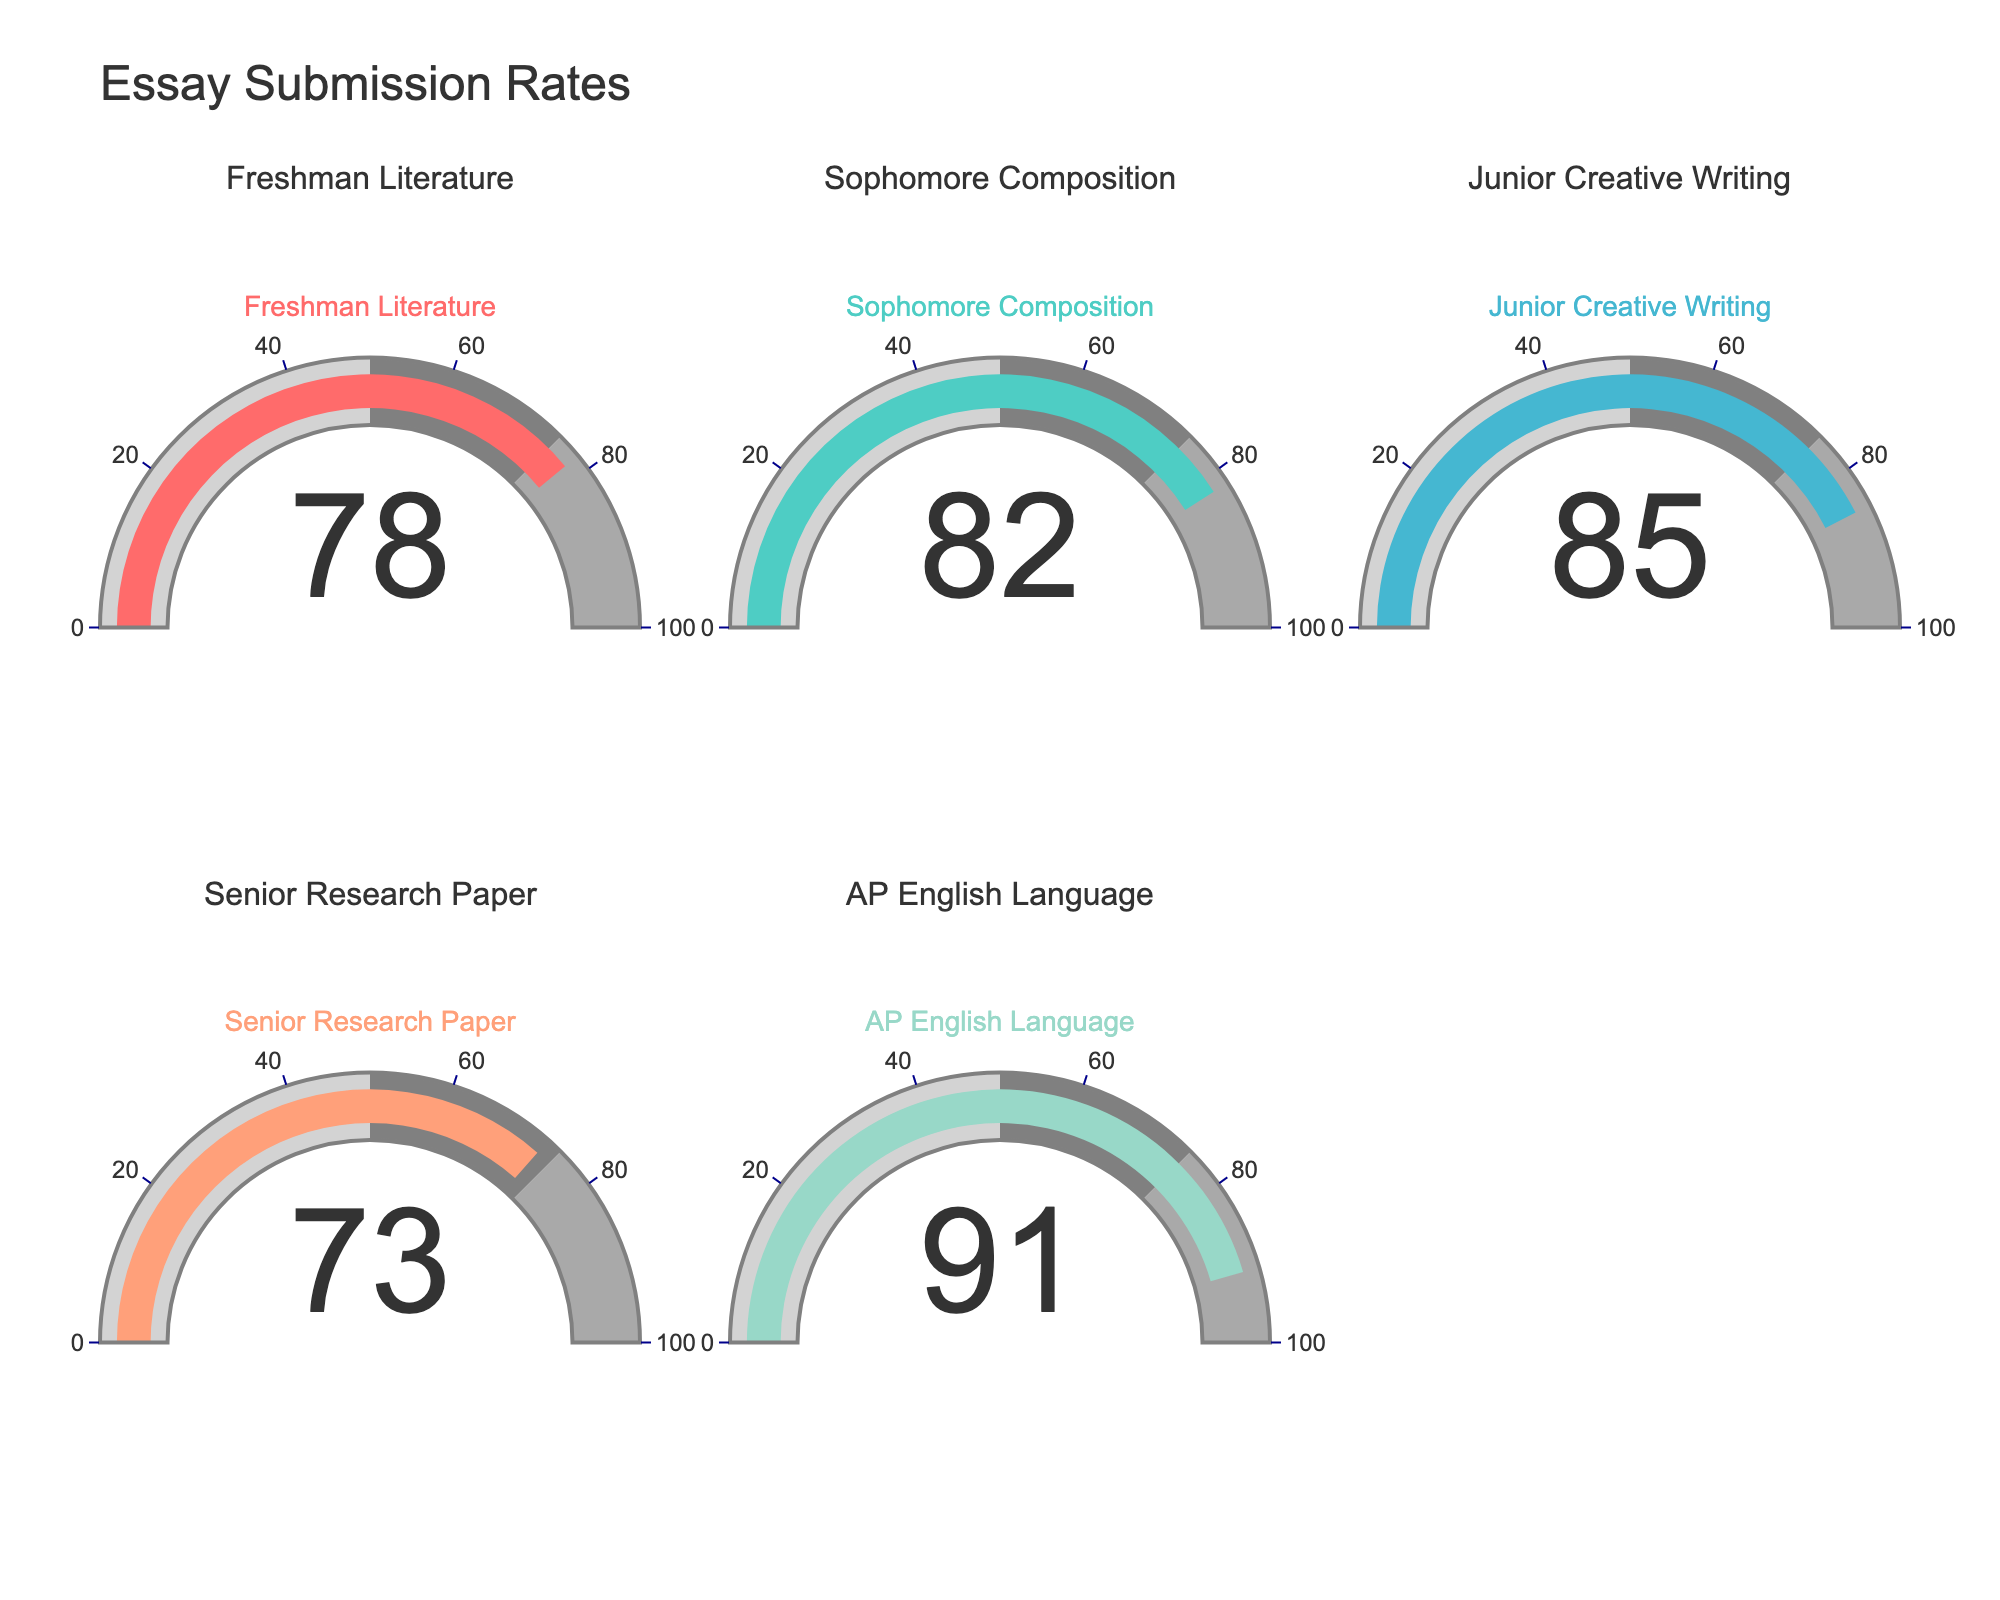What is the title of the chart? The title is found at the top of the chart, and it summarizes the overall topic of the figure. Look at the top center area for this information.
Answer: Essay Submission Rates Which subject has the highest percentage of essays submitted on time? Locate the gauge showing the highest percentage value. This will be the subject with the highest essay submission rate. The highest value is 91.
Answer: AP English Language What is the percentage of essays submitted on time for Junior Creative Writing? Find the gauge labeled "Junior Creative Writing." The number displayed on this gauge indicates the percentage of essays submitted on time.
Answer: 85 How many subjects have a submission rate of 80% or higher? Identify all gauges showing percentages of 80% or more. Count these gauges to determine the total number of subjects meeting this criterion.
Answer: 3 Which subject has the lowest percentage of essays submitted on time? Find the gauge showing the lowest percentage value. This will be the subject with the lowest essay submission rate. The lowest value is 73.
Answer: Senior Research Paper What is the difference between the highest and lowest percentage of essays submitted on time? Identify the highest value (91) and the lowest value (73) from the gauges. Subtract the lowest from the highest to find the difference. 91 - 73 = 18
Answer: 18 Is the percentage of essays submitted on time for Freshman Literature higher or lower than Sophomore Composition? Compare the percentages displayed on the gauges labeled "Freshman Literature" and "Sophomore Composition." Freshman Literature has 78 and Sophomore Composition has 82.
Answer: Lower What is the average percentage of essays submitted on time across all subjects? Add all the percentage values from each gauge (78 + 82 + 85 + 73 + 91) and divide by the number of subjects (5) to find the average. (78 + 82 + 85 + 73 + 91) / 5 = 81.8
Answer: 81.8 